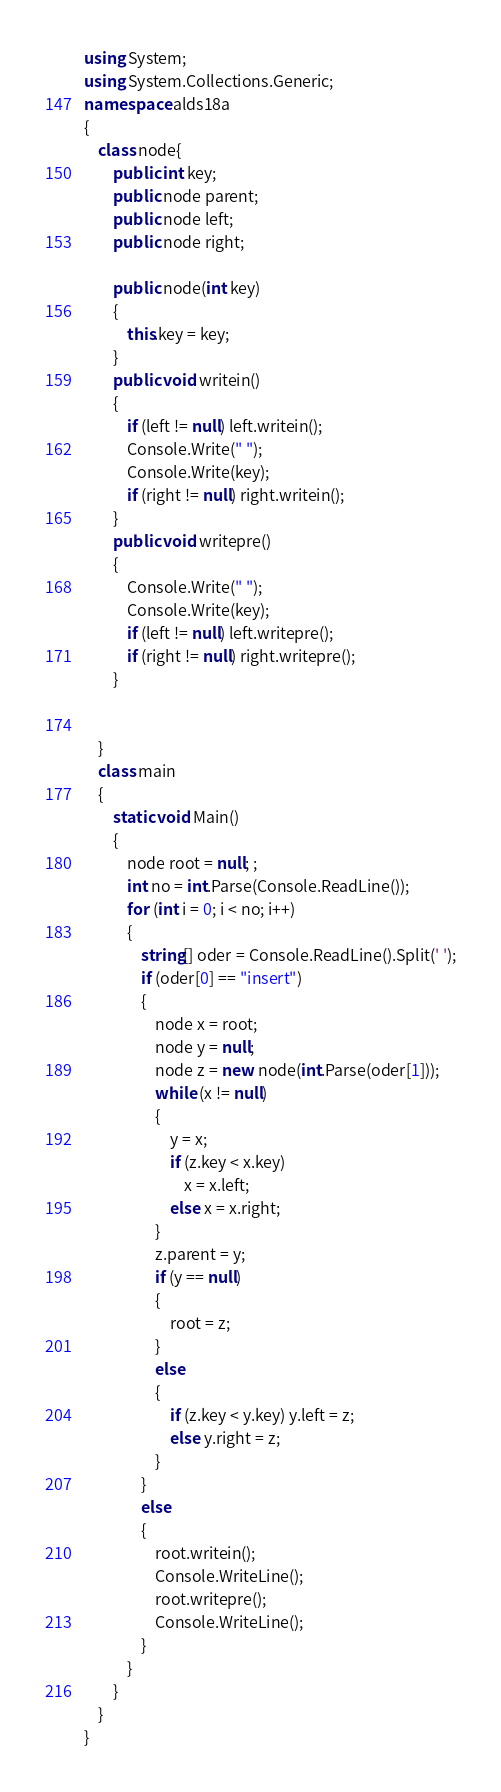<code> <loc_0><loc_0><loc_500><loc_500><_C#_>using System;
using System.Collections.Generic;
namespace alds18a
{
    class node{
        public int key;
        public node parent;
        public node left;
        public node right;

        public node(int key)
        {
            this.key = key;
        }
        public void writein()
        {
            if (left != null) left.writein();
            Console.Write(" ");
            Console.Write(key);
            if (right != null) right.writein();
        }
        public void writepre()
        {
            Console.Write(" ");
            Console.Write(key);
            if (left != null) left.writepre();
            if (right != null) right.writepre();
        }


    }
    class main
    {
        static void Main()
        {
            node root = null; ;
            int no = int.Parse(Console.ReadLine());
            for (int i = 0; i < no; i++)
            {
                string[] oder = Console.ReadLine().Split(' ');
                if (oder[0] == "insert")
                {
                    node x = root;
                    node y = null;
                    node z = new node(int.Parse(oder[1]));
                    while (x != null)
                    {
                        y = x;
                        if (z.key < x.key)
                            x = x.left;
                        else x = x.right;
                    }
                    z.parent = y;
                    if (y == null)
                    {
                        root = z;
                    }
                    else
                    {
                        if (z.key < y.key) y.left = z;
                        else y.right = z;
                    }
                }
                else
                {
                    root.writein();
                    Console.WriteLine();
                    root.writepre();
                    Console.WriteLine();
                }
            }
        }
    }
}</code> 